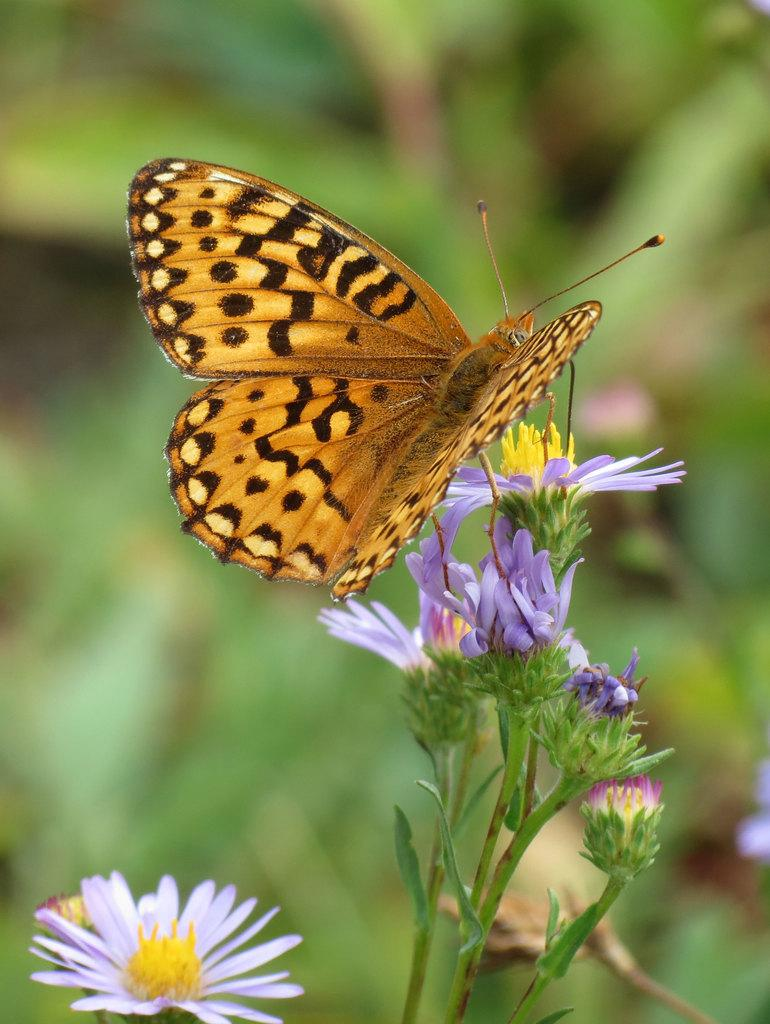What is the main subject of the image? There is a butterfly in the image. What is the butterfly doing in the image? The butterfly is standing on a plant. What type of flowers can be seen on the plants in the image? There are purple and pink color flowers on the plants. How would you describe the clarity of the image? The image is blurry at the back. What is the writer's opinion on the comparison between the butterfly and the seed in the image? There is no writer or comparison between the butterfly and a seed present in the image. 